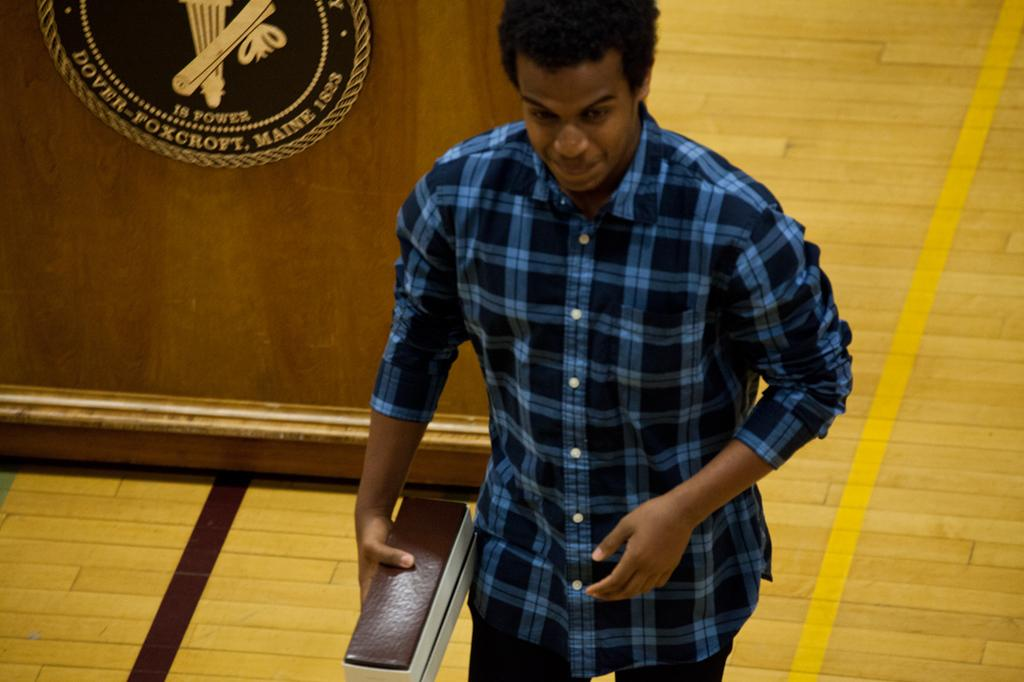What is the main subject of the image? There is a person in the center of the image. What is the person holding in the image? The person is holding an object. What can be seen in the background of the image? There is a podium in the background of the image. What is the surface on which the person is standing? There is a floor visible in the image. How many cats are sleeping on the podium in the image? There are no cats present in the image, and therefore no cats are sleeping on the podium. What type of kettle is visible on the floor in the image? There is no kettle visible on the floor in the image. 